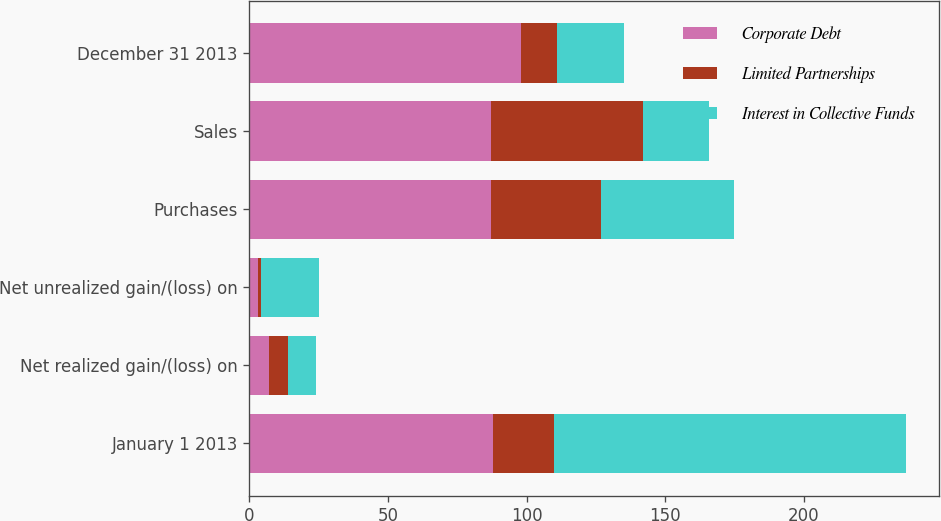Convert chart to OTSL. <chart><loc_0><loc_0><loc_500><loc_500><stacked_bar_chart><ecel><fcel>January 1 2013<fcel>Net realized gain/(loss) on<fcel>Net unrealized gain/(loss) on<fcel>Purchases<fcel>Sales<fcel>December 31 2013<nl><fcel>Corporate Debt<fcel>88<fcel>7<fcel>3<fcel>87<fcel>87<fcel>98<nl><fcel>Limited Partnerships<fcel>22<fcel>7<fcel>1<fcel>40<fcel>55<fcel>13<nl><fcel>Interest in Collective Funds<fcel>127<fcel>10<fcel>21<fcel>48<fcel>24<fcel>24<nl></chart> 